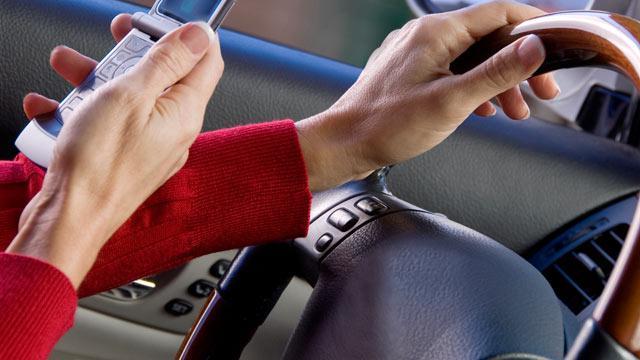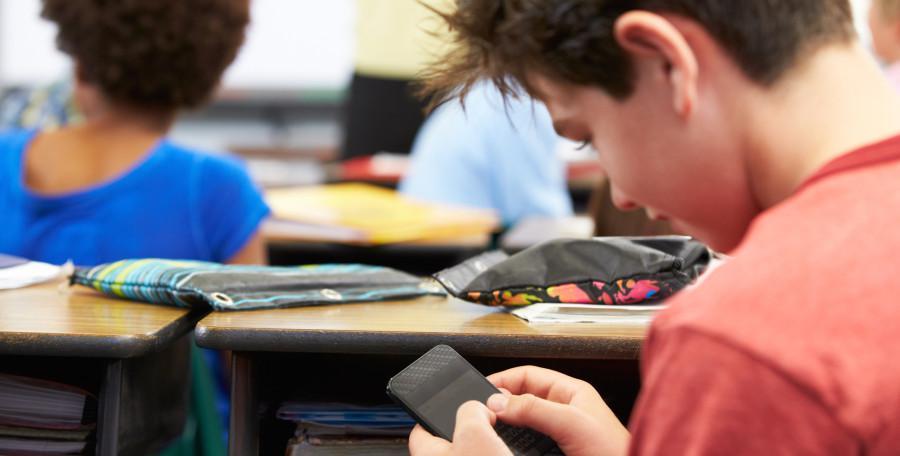The first image is the image on the left, the second image is the image on the right. Considering the images on both sides, is "A person is using a cell phone while in a car." valid? Answer yes or no. Yes. The first image is the image on the left, the second image is the image on the right. Analyze the images presented: Is the assertion "A person is driving and holding a cell phone in the left image." valid? Answer yes or no. Yes. 